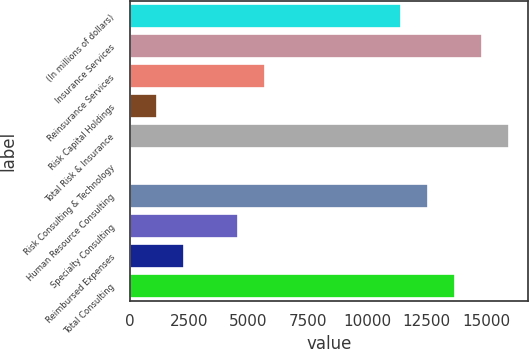<chart> <loc_0><loc_0><loc_500><loc_500><bar_chart><fcel>(In millions of dollars)<fcel>Insurance Services<fcel>Reinsurance Services<fcel>Risk Capital Holdings<fcel>Total Risk & Insurance<fcel>Risk Consulting & Technology<fcel>Human Resource Consulting<fcel>Specialty Consulting<fcel>Reimbursed Expenses<fcel>Total Consulting<nl><fcel>11397<fcel>14810.4<fcel>5708<fcel>1156.8<fcel>15948.2<fcel>19<fcel>12534.8<fcel>4570.2<fcel>2294.6<fcel>13672.6<nl></chart> 